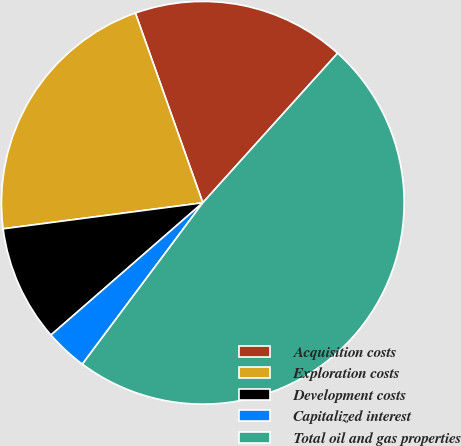<chart> <loc_0><loc_0><loc_500><loc_500><pie_chart><fcel>Acquisition costs<fcel>Exploration costs<fcel>Development costs<fcel>Capitalized interest<fcel>Total oil and gas properties<nl><fcel>17.11%<fcel>21.63%<fcel>9.34%<fcel>3.39%<fcel>48.53%<nl></chart> 